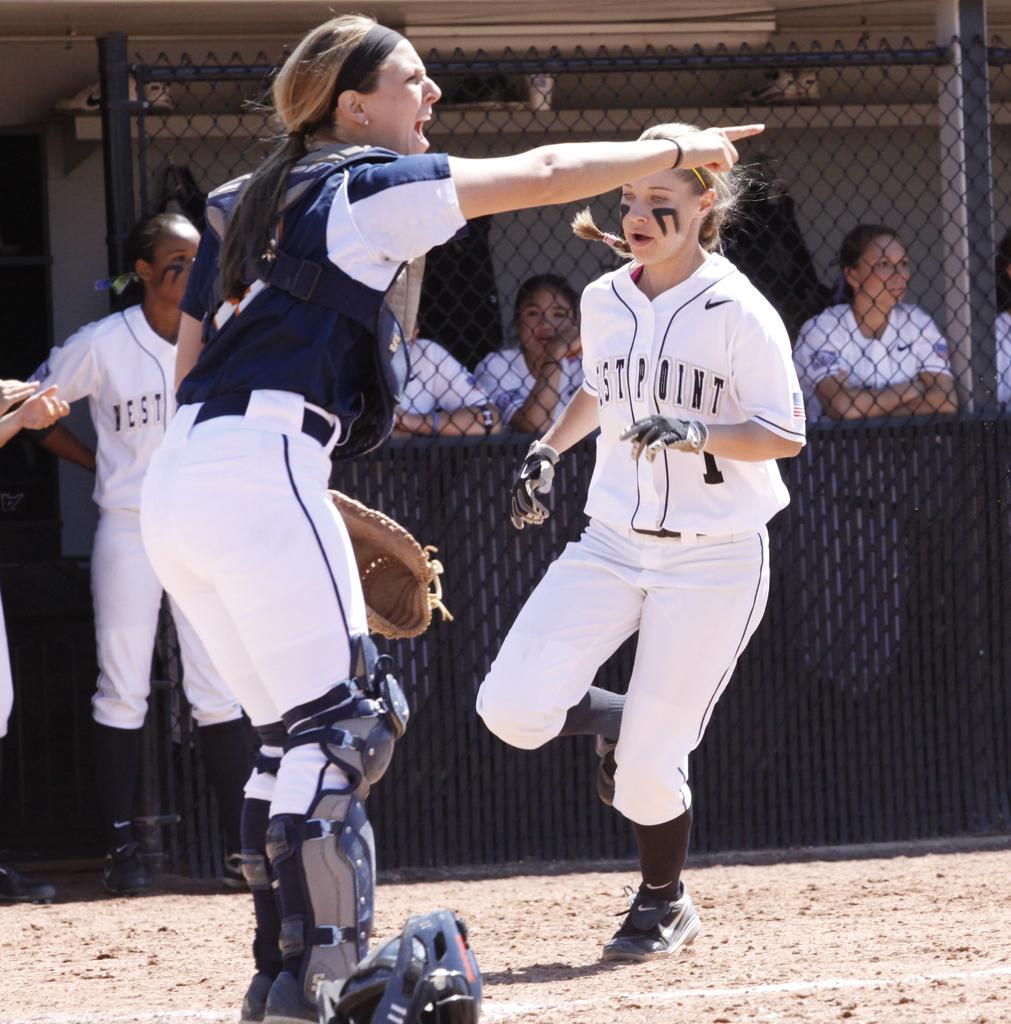<image>
Share a concise interpretation of the image provided. the name westpoint is on the jersey of a person 